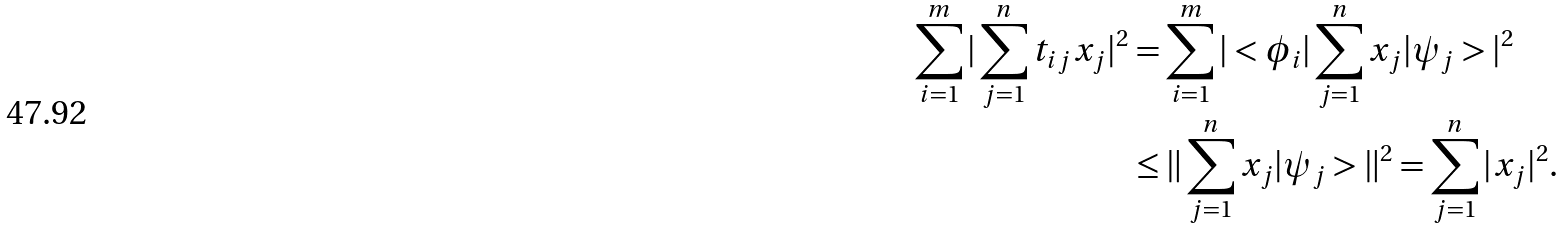<formula> <loc_0><loc_0><loc_500><loc_500>\sum _ { i = 1 } ^ { m } | \sum _ { j = 1 } ^ { n } t _ { i j } x _ { j } | ^ { 2 } & = \sum _ { i = 1 } ^ { m } | < \phi _ { i } | \sum _ { j = 1 } ^ { n } x _ { j } | \psi _ { j } > | ^ { 2 } \\ & \leq \| \sum _ { j = 1 } ^ { n } x _ { j } | \psi _ { j } > \| ^ { 2 } = \sum _ { j = 1 } ^ { n } | x _ { j } | ^ { 2 } .</formula> 